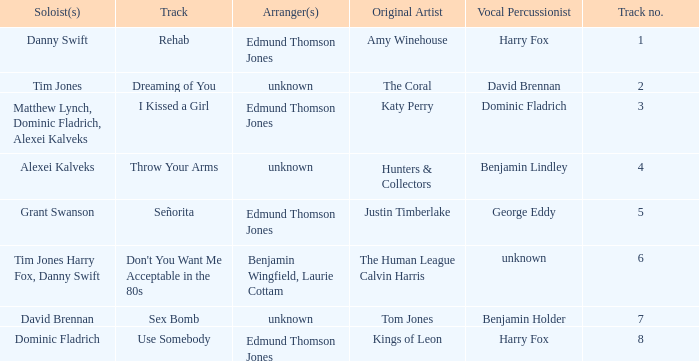Who is the artist where the vocal percussionist is Benjamin Holder? Tom Jones. 